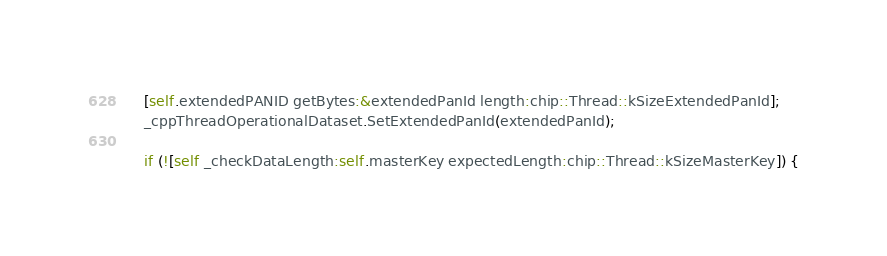<code> <loc_0><loc_0><loc_500><loc_500><_ObjectiveC_>    [self.extendedPANID getBytes:&extendedPanId length:chip::Thread::kSizeExtendedPanId];
    _cppThreadOperationalDataset.SetExtendedPanId(extendedPanId);

    if (![self _checkDataLength:self.masterKey expectedLength:chip::Thread::kSizeMasterKey]) {</code> 